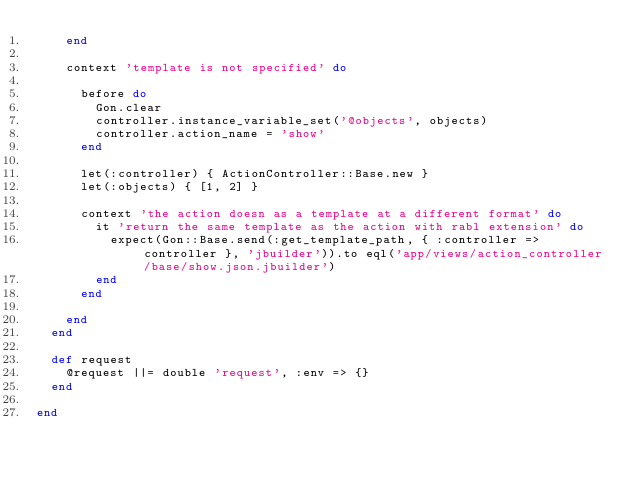<code> <loc_0><loc_0><loc_500><loc_500><_Ruby_>    end

    context 'template is not specified' do

      before do
        Gon.clear
        controller.instance_variable_set('@objects', objects)
        controller.action_name = 'show'
      end

      let(:controller) { ActionController::Base.new }
      let(:objects) { [1, 2] }

      context 'the action doesn as a template at a different format' do
        it 'return the same template as the action with rabl extension' do
          expect(Gon::Base.send(:get_template_path, { :controller => controller }, 'jbuilder')).to eql('app/views/action_controller/base/show.json.jbuilder')
        end
      end

    end
  end

  def request
    @request ||= double 'request', :env => {}
  end

end
</code> 